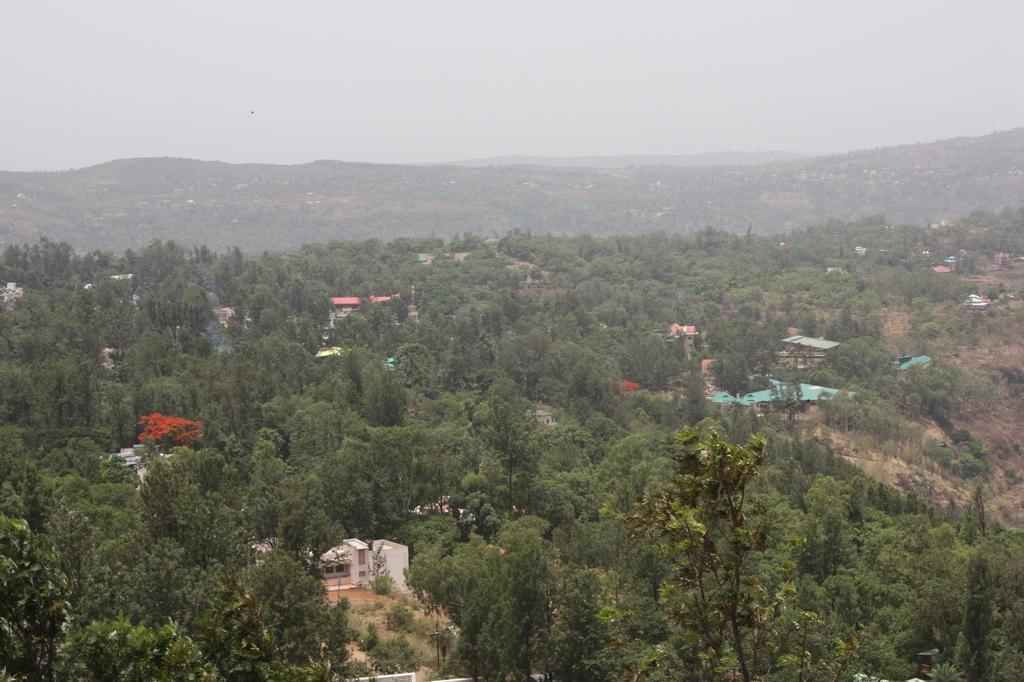How would you summarize this image in a sentence or two? This picture might be aerial view of a city. In this image, we can see some houses, satellites, trees, plants, mountains, rocks. On the top, we can see a sky. 